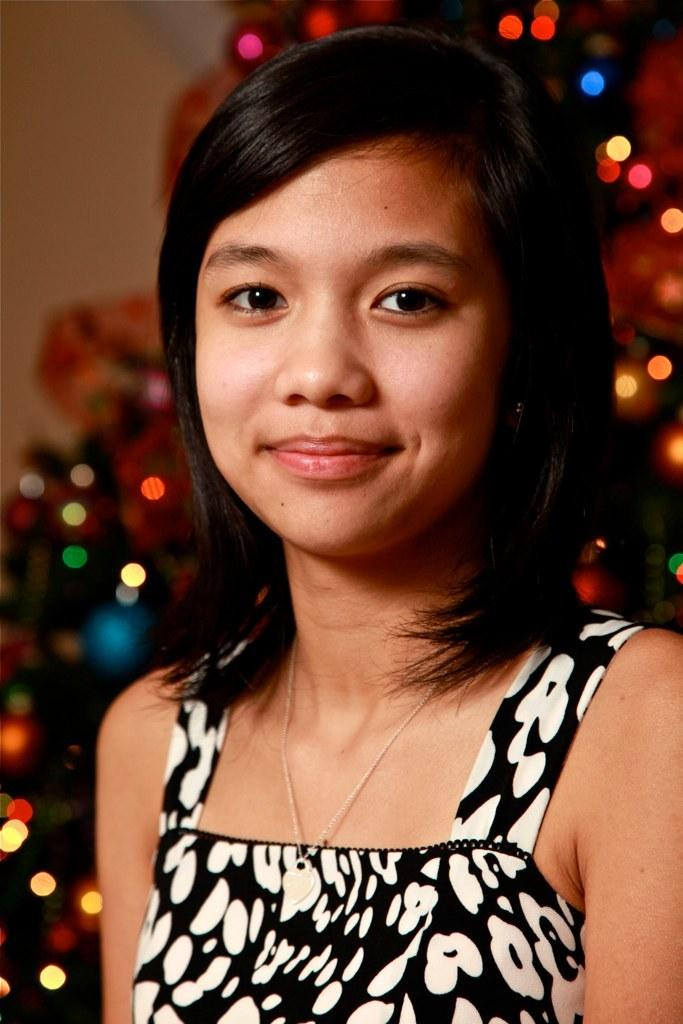Who is present in the image? There is a woman in the image. What expression does the woman have? The woman is smiling. What can be seen behind the woman in the image? There are lights visible behind the woman. What type of quilt is being used to create the lighting effect in the image? There is no quilt or lighting effect present in the image; it simply features a woman smiling with lights visible behind her. 